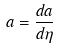<formula> <loc_0><loc_0><loc_500><loc_500>a = \frac { d a } { d \eta }</formula> 